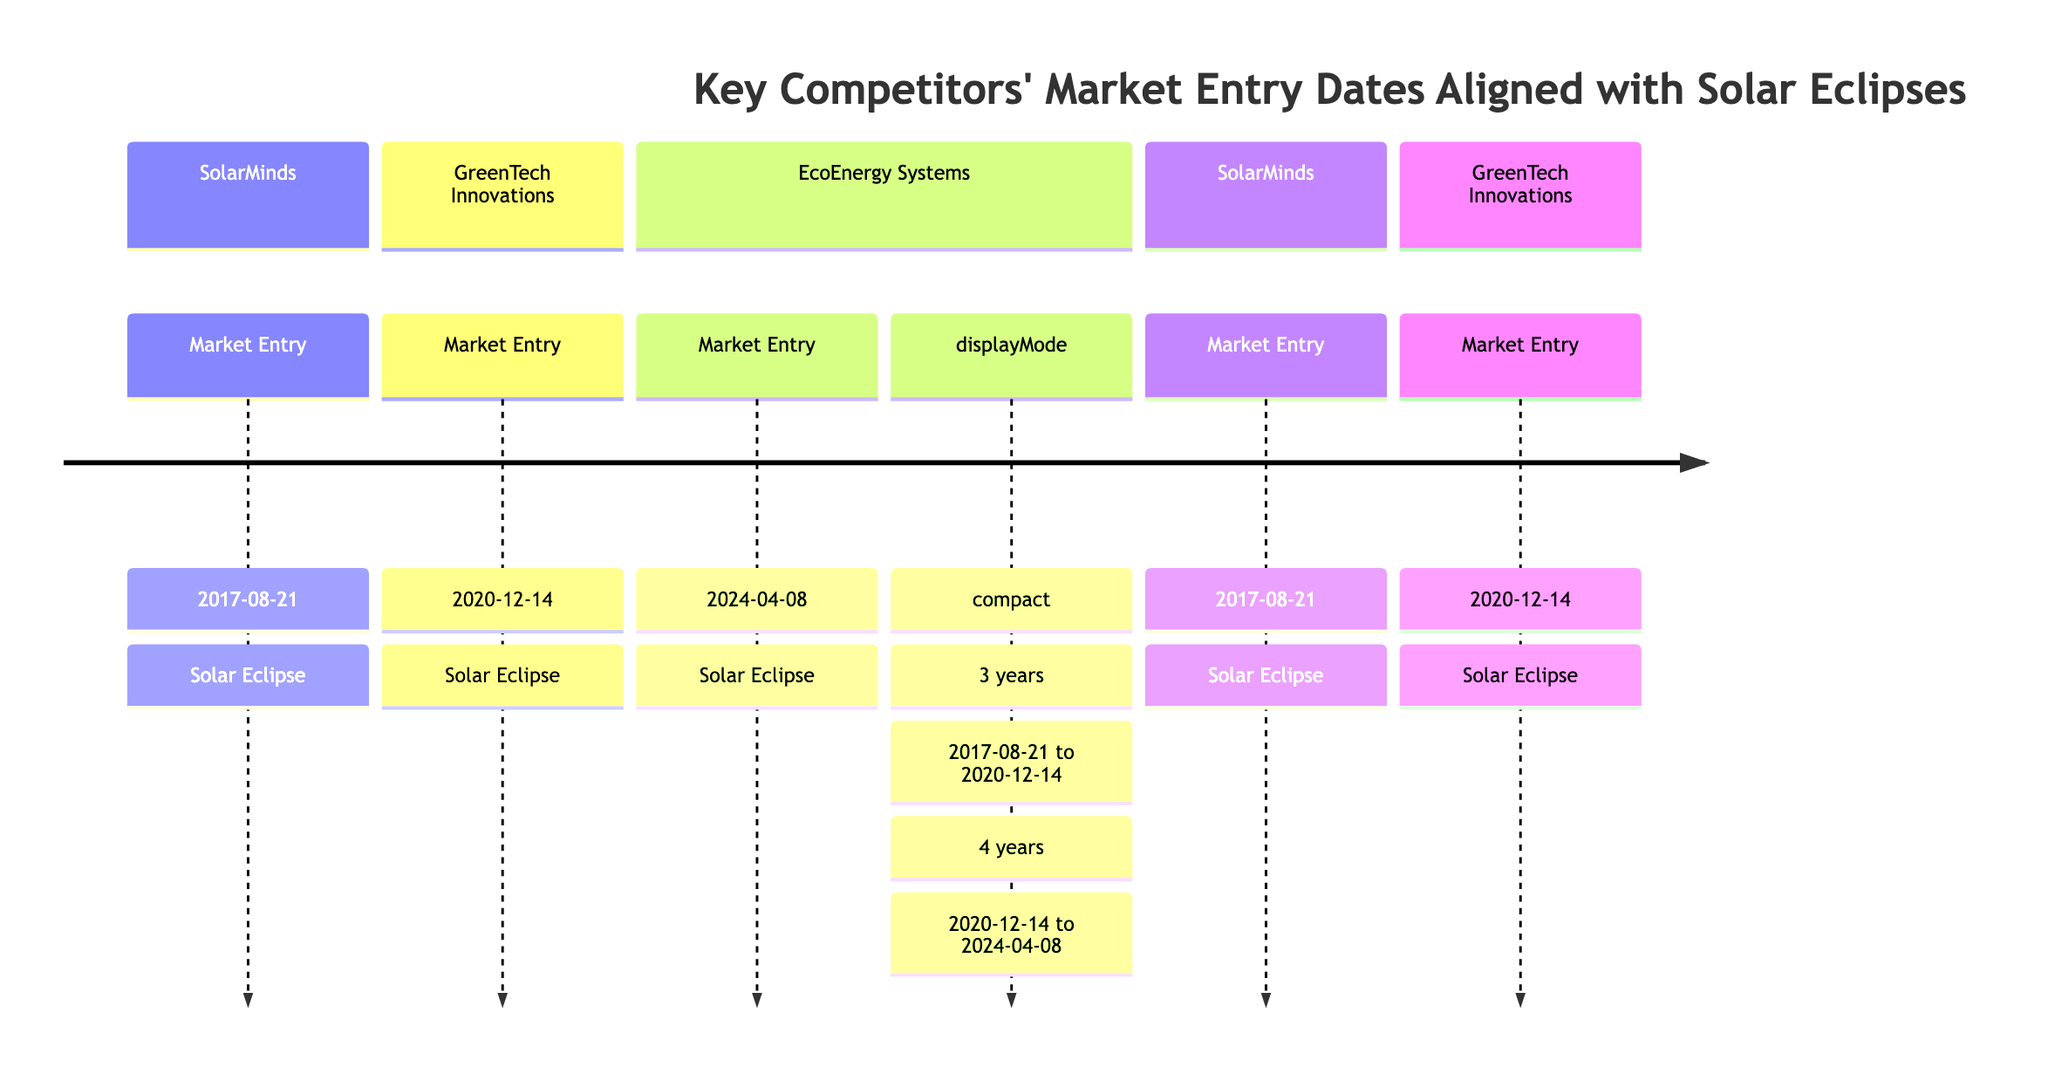What is the market entry date for SolarMinds? The diagram indicates that SolarMinds entered the market on August 21, 2017, as seen in the timeline section dedicated to SolarMinds.
Answer: August 21, 2017 How many years passed between SolarMinds' and GreenTech Innovations' market entries? By examining the timeline, SolarMinds entered in August 2017 and GreenTech Innovations in December 2020, which is a period of 3 years and 4 months, but specifically mentioned as "3 years" in the timeline section.
Answer: 3 years Who entered the market after GreenTech Innovations? The timeline shows that EcoEnergy Systems entered the market after GreenTech Innovations, specifically highlighted in the section after GreenTech Innovations' entry date.
Answer: EcoEnergy Systems What celestial event is associated with EcoEnergy Systems’ market entry? The diagram specifies that EcoEnergy Systems' market entry is aligned with a solar eclipse, which is explicitly stated next to the market entry date of April 8, 2024.
Answer: Solar Eclipse What is the time span between GreenTech Innovations and EcoEnergy Systems’ market entries? The timeline indicates a gap of 4 years from GreenTech Innovations' entry on December 14, 2020, to EcoEnergy Systems' entry on April 8, 2024, as stated in the section dedicated to GreenTech Innovations.
Answer: 4 years How many total key competitors are shown in the diagram? Analyzing the diagram, there are three key competitors listed: SolarMinds, GreenTech Innovations, and EcoEnergy Systems, which can be counted directly from the timeline sections.
Answer: 3 Which competitor had the first market entry? By looking at the timeline, it is clear that SolarMinds, with an entry date of August 21, 2017, is the first competitor listed, preceding both GreenTech Innovations and EcoEnergy Systems.
Answer: SolarMinds What is the relationship between competitors' entries and solar eclipses in this diagram? The diagram shows that each competitor's market entry date is aligned with a solar eclipse, indicating a deliberate strategy to enter the market during significant celestial events, noted next to each entry.
Answer: Aligned with Solar Eclipses 